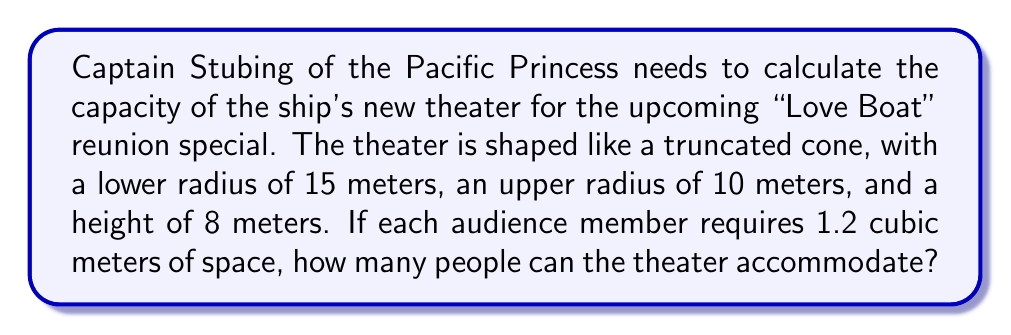Provide a solution to this math problem. Let's approach this step-by-step:

1) First, we need to calculate the volume of the truncated cone. The formula for the volume of a truncated cone is:

   $$V = \frac{1}{3}\pi h(R^2 + r^2 + Rr)$$

   Where:
   $h$ = height
   $R$ = radius of the base
   $r$ = radius of the top

2) We have:
   $h = 8$ meters
   $R = 15$ meters
   $r = 10$ meters

3) Let's substitute these values into the formula:

   $$V = \frac{1}{3}\pi \cdot 8(15^2 + 10^2 + 15 \cdot 10)$$

4) Simplify:
   $$V = \frac{8\pi}{3}(225 + 100 + 150)$$
   $$V = \frac{8\pi}{3}(475)$$

5) Calculate:
   $$V \approx 3167.26 \text{ cubic meters}$$

6) Now, we need to divide this volume by the space required per person:

   $$\text{Number of people} = \frac{3167.26}{1.2} \approx 2639.38$$

7) Since we can't have a fractional person, we round down to the nearest whole number.
Answer: 2639 people 